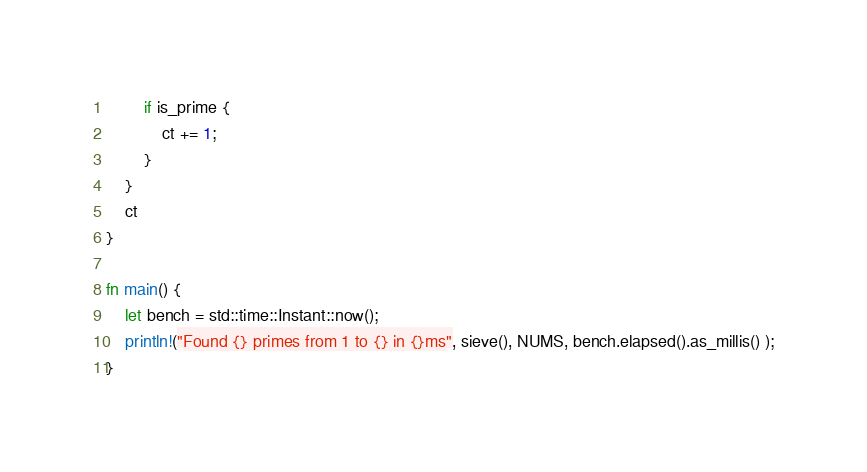Convert code to text. <code><loc_0><loc_0><loc_500><loc_500><_Rust_>        if is_prime {
            ct += 1;
        }
    }
    ct
}

fn main() {
    let bench = std::time::Instant::now();
    println!("Found {} primes from 1 to {} in {}ms", sieve(), NUMS, bench.elapsed().as_millis() );
}
</code> 